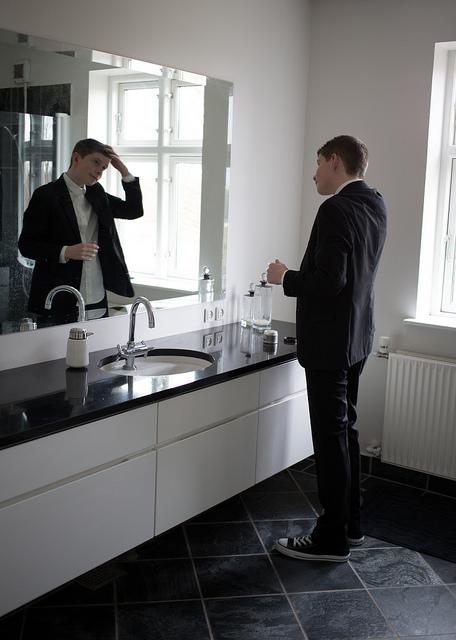Is the man barefoot?
Write a very short answer. No. What room is the man in?
Keep it brief. Bathroom. Does the mirror have a frame?
Short answer required. No. 